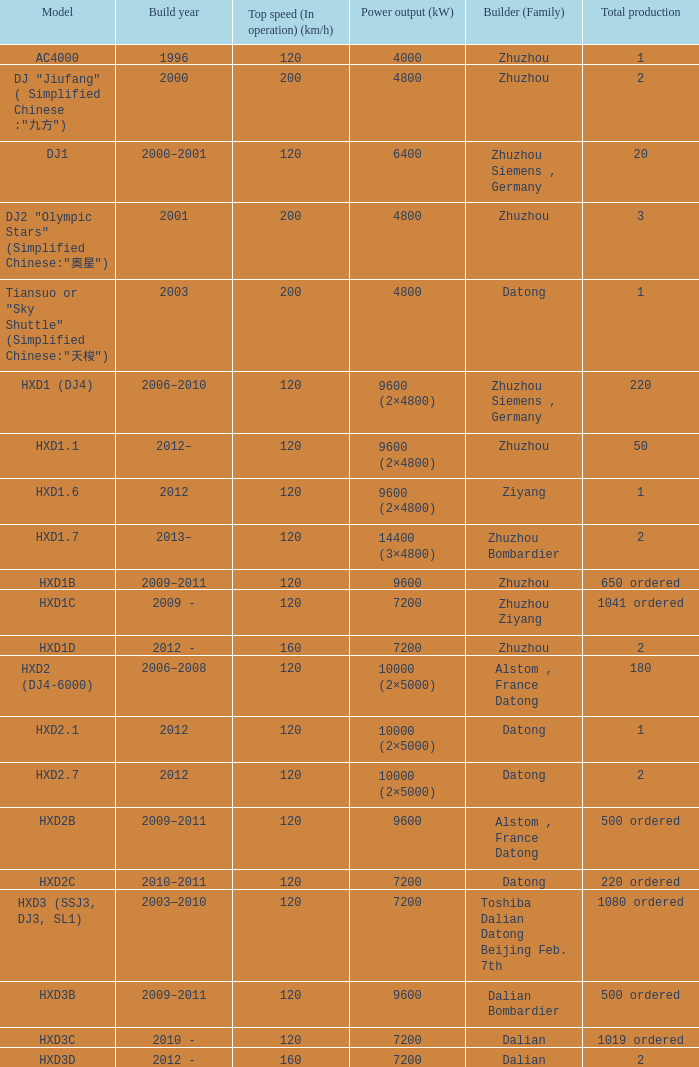What blueprint has a creator of zhuzhou, and a power generation of 9600 (kw)? HXD1B. 